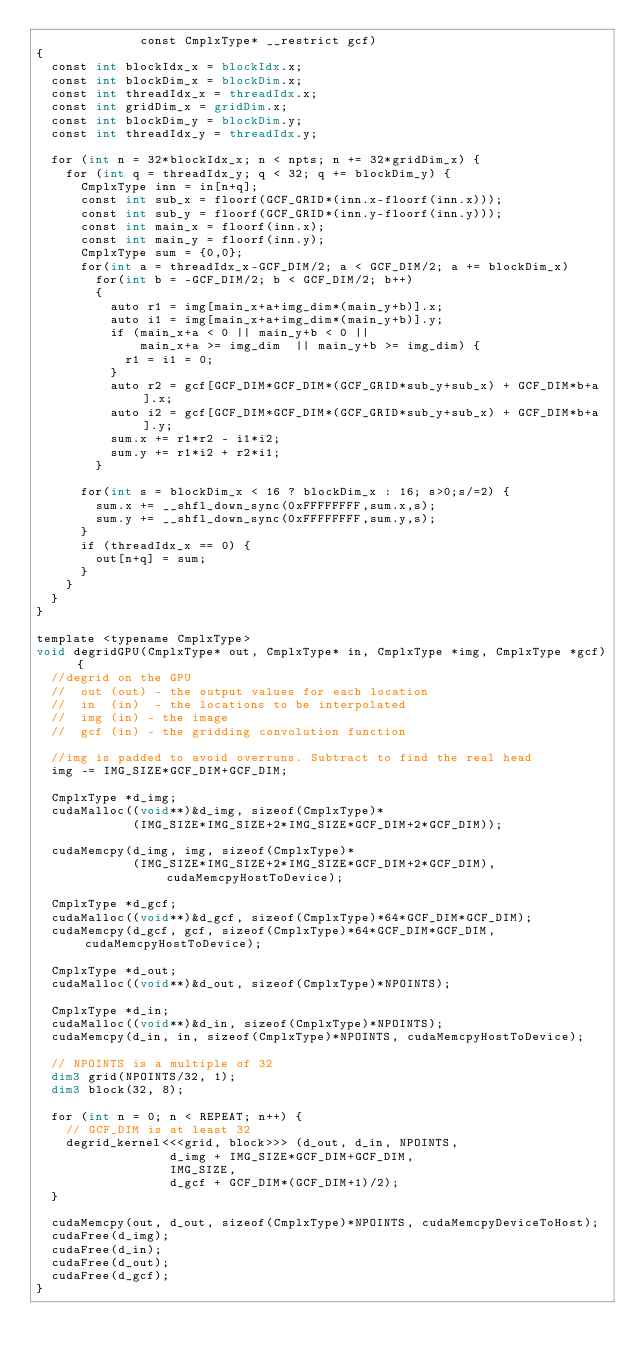Convert code to text. <code><loc_0><loc_0><loc_500><loc_500><_Cuda_>              const CmplxType* __restrict gcf)
{
  const int blockIdx_x = blockIdx.x; 
  const int blockDim_x = blockDim.x; 
  const int threadIdx_x = threadIdx.x; 
  const int gridDim_x = gridDim.x; 
  const int blockDim_y = blockDim.y; 
  const int threadIdx_y = threadIdx.y;

  for (int n = 32*blockIdx_x; n < npts; n += 32*gridDim_x) {
    for (int q = threadIdx_y; q < 32; q += blockDim_y) {
      CmplxType inn = in[n+q];
      const int sub_x = floorf(GCF_GRID*(inn.x-floorf(inn.x)));
      const int sub_y = floorf(GCF_GRID*(inn.y-floorf(inn.y)));
      const int main_x = floorf(inn.x); 
      const int main_y = floorf(inn.y); 
      CmplxType sum = {0,0};
      for(int a = threadIdx_x-GCF_DIM/2; a < GCF_DIM/2; a += blockDim_x)
        for(int b = -GCF_DIM/2; b < GCF_DIM/2; b++)
        {
          auto r1 = img[main_x+a+img_dim*(main_y+b)].x; 
          auto i1 = img[main_x+a+img_dim*(main_y+b)].y; 
          if (main_x+a < 0 || main_y+b < 0 || 
              main_x+a >= img_dim  || main_y+b >= img_dim) {
            r1 = i1 = 0;
          }
          auto r2 = gcf[GCF_DIM*GCF_DIM*(GCF_GRID*sub_y+sub_x) + GCF_DIM*b+a].x;
          auto i2 = gcf[GCF_DIM*GCF_DIM*(GCF_GRID*sub_y+sub_x) + GCF_DIM*b+a].y;
          sum.x += r1*r2 - i1*i2; 
          sum.y += r1*i2 + r2*i1;
        }

      for(int s = blockDim_x < 16 ? blockDim_x : 16; s>0;s/=2) {
        sum.x += __shfl_down_sync(0xFFFFFFFF,sum.x,s);
        sum.y += __shfl_down_sync(0xFFFFFFFF,sum.y,s);
      }
      if (threadIdx_x == 0) {
        out[n+q] = sum;
      }
    }
  }
}

template <typename CmplxType>
void degridGPU(CmplxType* out, CmplxType* in, CmplxType *img, CmplxType *gcf) {
  //degrid on the GPU
  //  out (out) - the output values for each location
  //  in  (in)  - the locations to be interpolated 
  //  img (in) - the image
  //  gcf (in) - the gridding convolution function

  //img is padded to avoid overruns. Subtract to find the real head
  img -= IMG_SIZE*GCF_DIM+GCF_DIM;

  CmplxType *d_img;
  cudaMalloc((void**)&d_img, sizeof(CmplxType)*
             (IMG_SIZE*IMG_SIZE+2*IMG_SIZE*GCF_DIM+2*GCF_DIM));

  cudaMemcpy(d_img, img, sizeof(CmplxType)*
             (IMG_SIZE*IMG_SIZE+2*IMG_SIZE*GCF_DIM+2*GCF_DIM), cudaMemcpyHostToDevice);

  CmplxType *d_gcf;
  cudaMalloc((void**)&d_gcf, sizeof(CmplxType)*64*GCF_DIM*GCF_DIM);
  cudaMemcpy(d_gcf, gcf, sizeof(CmplxType)*64*GCF_DIM*GCF_DIM, cudaMemcpyHostToDevice);

  CmplxType *d_out;
  cudaMalloc((void**)&d_out, sizeof(CmplxType)*NPOINTS);

  CmplxType *d_in;
  cudaMalloc((void**)&d_in, sizeof(CmplxType)*NPOINTS);
  cudaMemcpy(d_in, in, sizeof(CmplxType)*NPOINTS, cudaMemcpyHostToDevice);

  // NPOINTS is a multiple of 32
  dim3 grid(NPOINTS/32, 1);
  dim3 block(32, 8);

  for (int n = 0; n < REPEAT; n++) {
    // GCF_DIM is at least 32
    degrid_kernel<<<grid, block>>> (d_out, d_in, NPOINTS,
                  d_img + IMG_SIZE*GCF_DIM+GCF_DIM,
                  IMG_SIZE,
                  d_gcf + GCF_DIM*(GCF_DIM+1)/2);
  }

  cudaMemcpy(out, d_out, sizeof(CmplxType)*NPOINTS, cudaMemcpyDeviceToHost);
  cudaFree(d_img);
  cudaFree(d_in);
  cudaFree(d_out);
  cudaFree(d_gcf);
}
</code> 